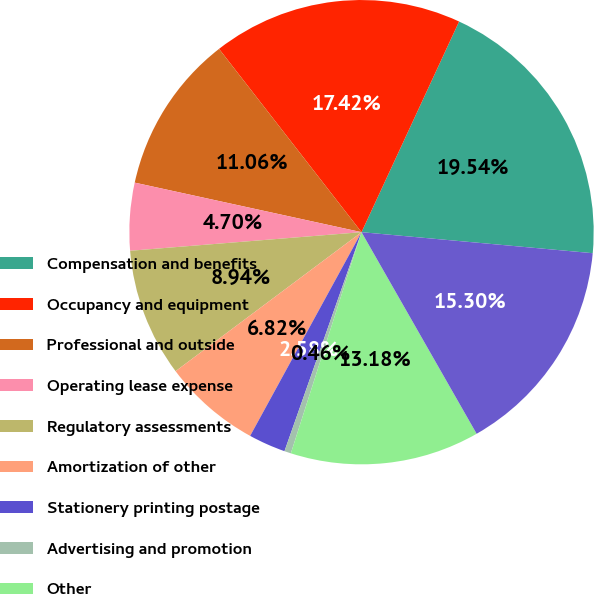<chart> <loc_0><loc_0><loc_500><loc_500><pie_chart><fcel>Compensation and benefits<fcel>Occupancy and equipment<fcel>Professional and outside<fcel>Operating lease expense<fcel>Regulatory assessments<fcel>Amortization of other<fcel>Stationery printing postage<fcel>Advertising and promotion<fcel>Other<fcel>Total other non-interest<nl><fcel>19.54%<fcel>17.42%<fcel>11.06%<fcel>4.7%<fcel>8.94%<fcel>6.82%<fcel>2.58%<fcel>0.46%<fcel>13.18%<fcel>15.3%<nl></chart> 